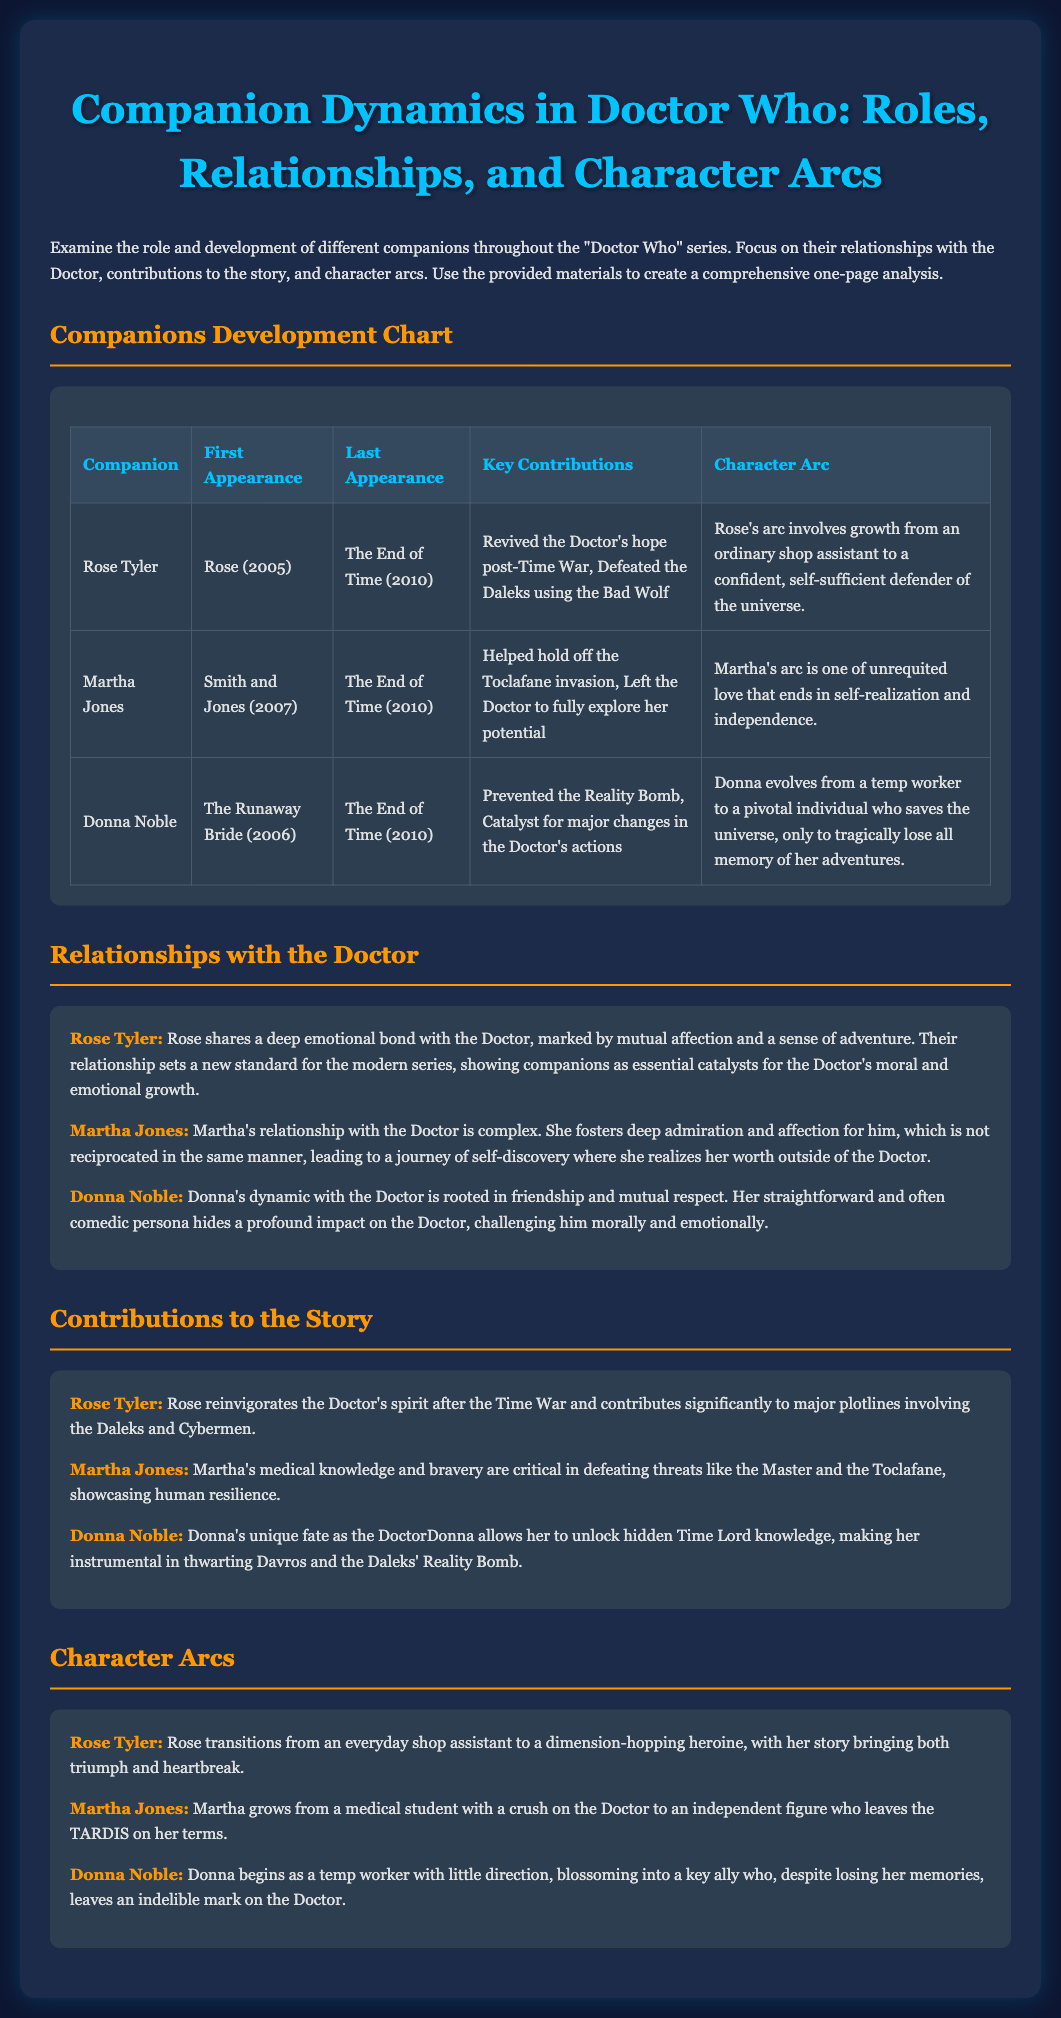What is the title of the document? The title is prominently displayed in the header of the document, which is "Companion Dynamics in Doctor Who: Roles, Relationships, and Character Arcs."
Answer: Companion Dynamics in Doctor Who: Roles, Relationships, and Character Arcs Who was the first companion listed? The first companion's name is provided in the "Companions Development Chart," which is Rose Tyler.
Answer: Rose Tyler What year did Donna Noble first appear? The first appearance year for Donna Noble can be found in the table, which states "2006."
Answer: 2006 Which companion is noted for helping hold off the Toclafane invasion? This specific contribution is tied to Martha Jones as highlighted in the chart.
Answer: Martha Jones What character arc is associated with Rose Tyler? The character arc for Rose Tyler is detailed in the corresponding section, indicating significant growth in confidence and responsibility.
Answer: growth from an ordinary shop assistant to a confident, self-sufficient defender of the universe What is the last appearance episode for Martha Jones? The last episode Martha Jones appears in, according to the chart, is "The End of Time."
Answer: The End of Time How did Donna Noble's character evolve? The solid evolution of Donna Noble is summarized in her character arc, showing her development into a pivotal savior of the universe.
Answer: from a temp worker to a pivotal individual who saves the universe What type of relationship did Rose Tyler share with the Doctor? The type of relationship is highlighted in the summary section, indicating a deep emotional bond.
Answer: deep emotional bond What unique capability did Donna Noble have as the DoctorDonna? Donna Noble's unique capability, as mentioned in the document, allowed her to unlock hidden Time Lord knowledge, making her instrumental in certain plots.
Answer: unlock hidden Time Lord knowledge 